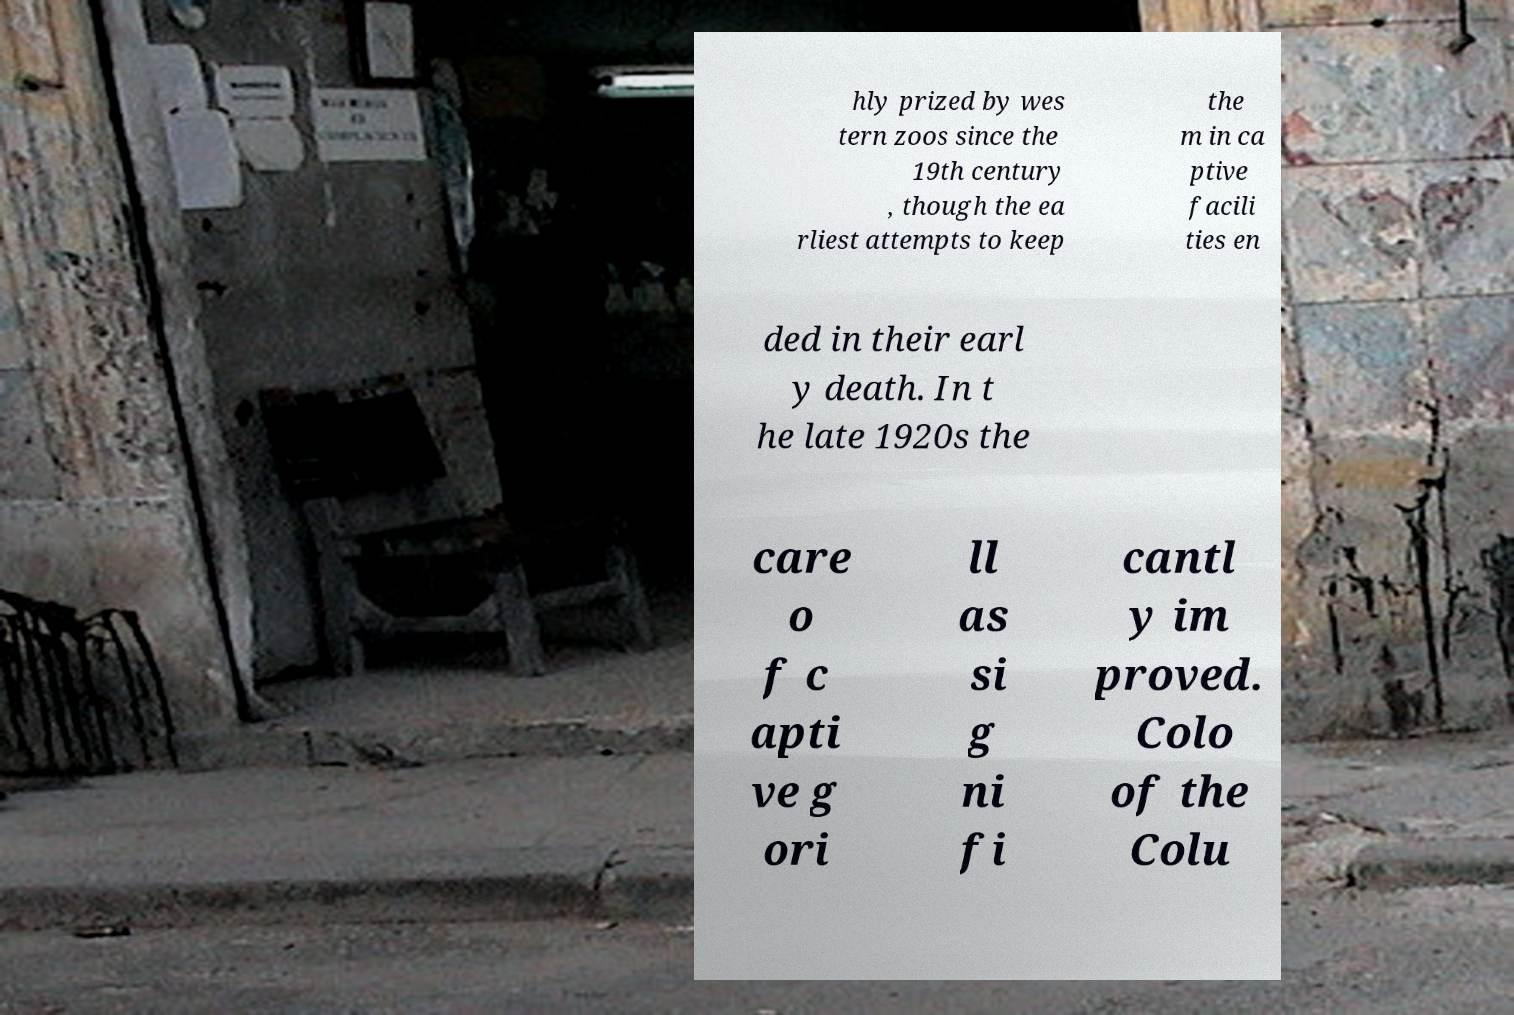What messages or text are displayed in this image? I need them in a readable, typed format. hly prized by wes tern zoos since the 19th century , though the ea rliest attempts to keep the m in ca ptive facili ties en ded in their earl y death. In t he late 1920s the care o f c apti ve g ori ll as si g ni fi cantl y im proved. Colo of the Colu 